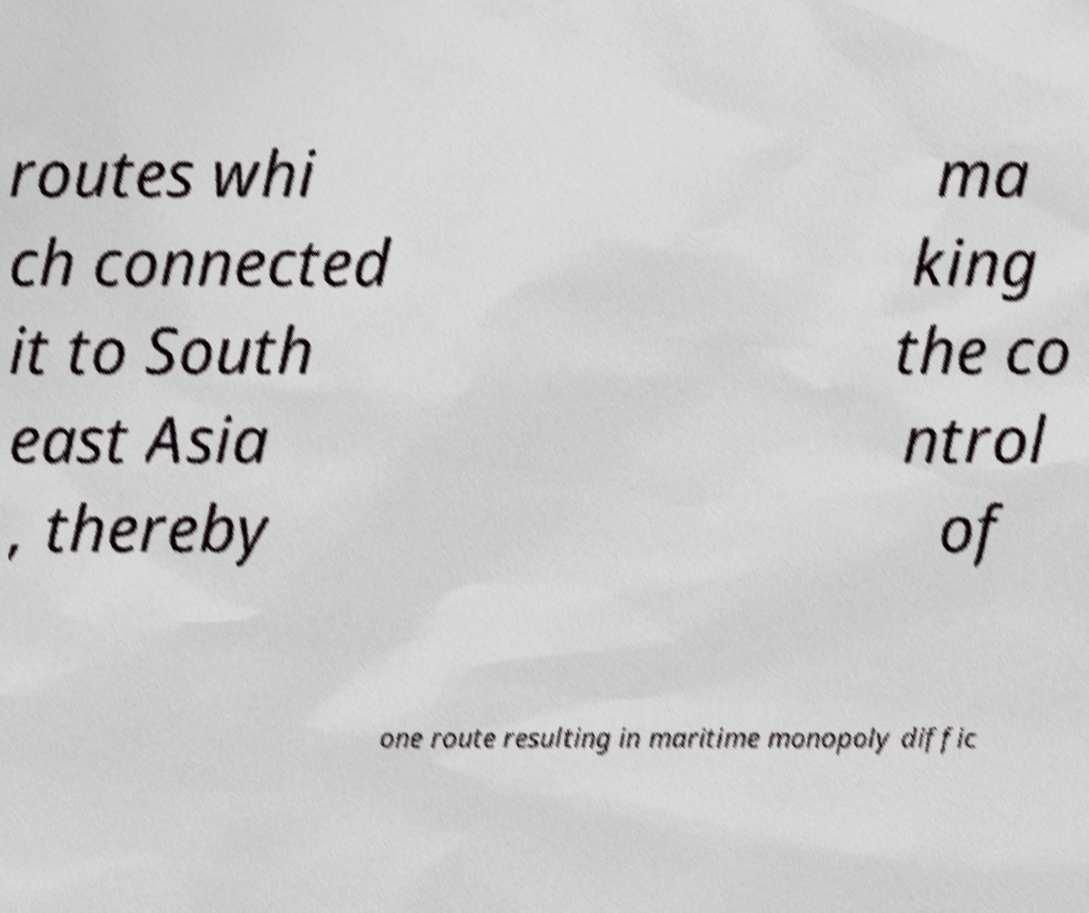Please read and relay the text visible in this image. What does it say? routes whi ch connected it to South east Asia , thereby ma king the co ntrol of one route resulting in maritime monopoly diffic 